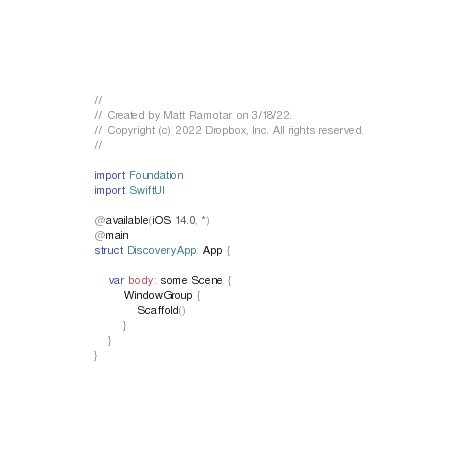Convert code to text. <code><loc_0><loc_0><loc_500><loc_500><_Swift_>//
// Created by Matt Ramotar on 3/18/22.
// Copyright (c) 2022 Dropbox, Inc. All rights reserved.
//

import Foundation
import SwiftUI

@available(iOS 14.0, *)
@main
struct DiscoveryApp: App {

    var body: some Scene {
        WindowGroup {
            Scaffold()
        }
    }
}
</code> 